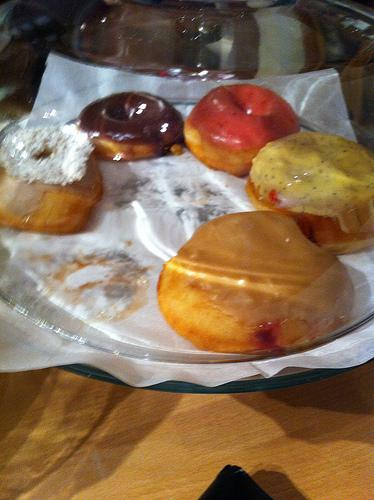Question: why isn't the plate full?
Choices:
A. Some donuts fell off.
B. Some donuts walked away.
C. Some donuts have been taken.
D. The plate grew.
Answer with the letter. Answer: C Question: who made the donuts?
Choices:
A. A machine.
B. Krispy Kreme staff.
C. A baker.
D. Mom.
Answer with the letter. Answer: C Question: where are the donuts?
Choices:
A. On a plate.
B. In a bakery box.
C. In a bowl.
D. On a tray.
Answer with the letter. Answer: A Question: what is the white substance on one of the donuts?
Choices:
A. Coconut.
B. Glaze.
C. Powdered sugar.
D. Frosting.
Answer with the letter. Answer: A 